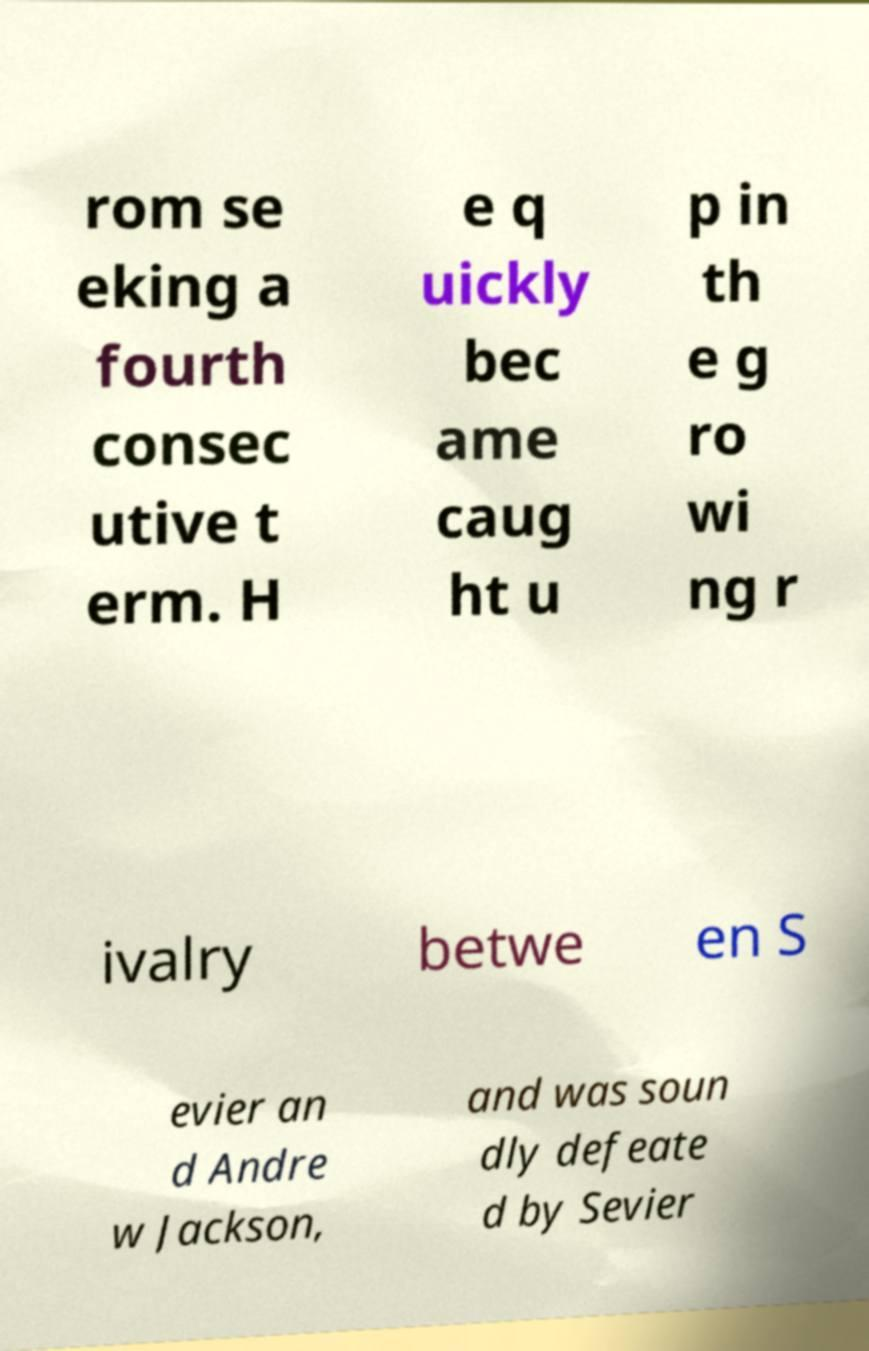For documentation purposes, I need the text within this image transcribed. Could you provide that? rom se eking a fourth consec utive t erm. H e q uickly bec ame caug ht u p in th e g ro wi ng r ivalry betwe en S evier an d Andre w Jackson, and was soun dly defeate d by Sevier 